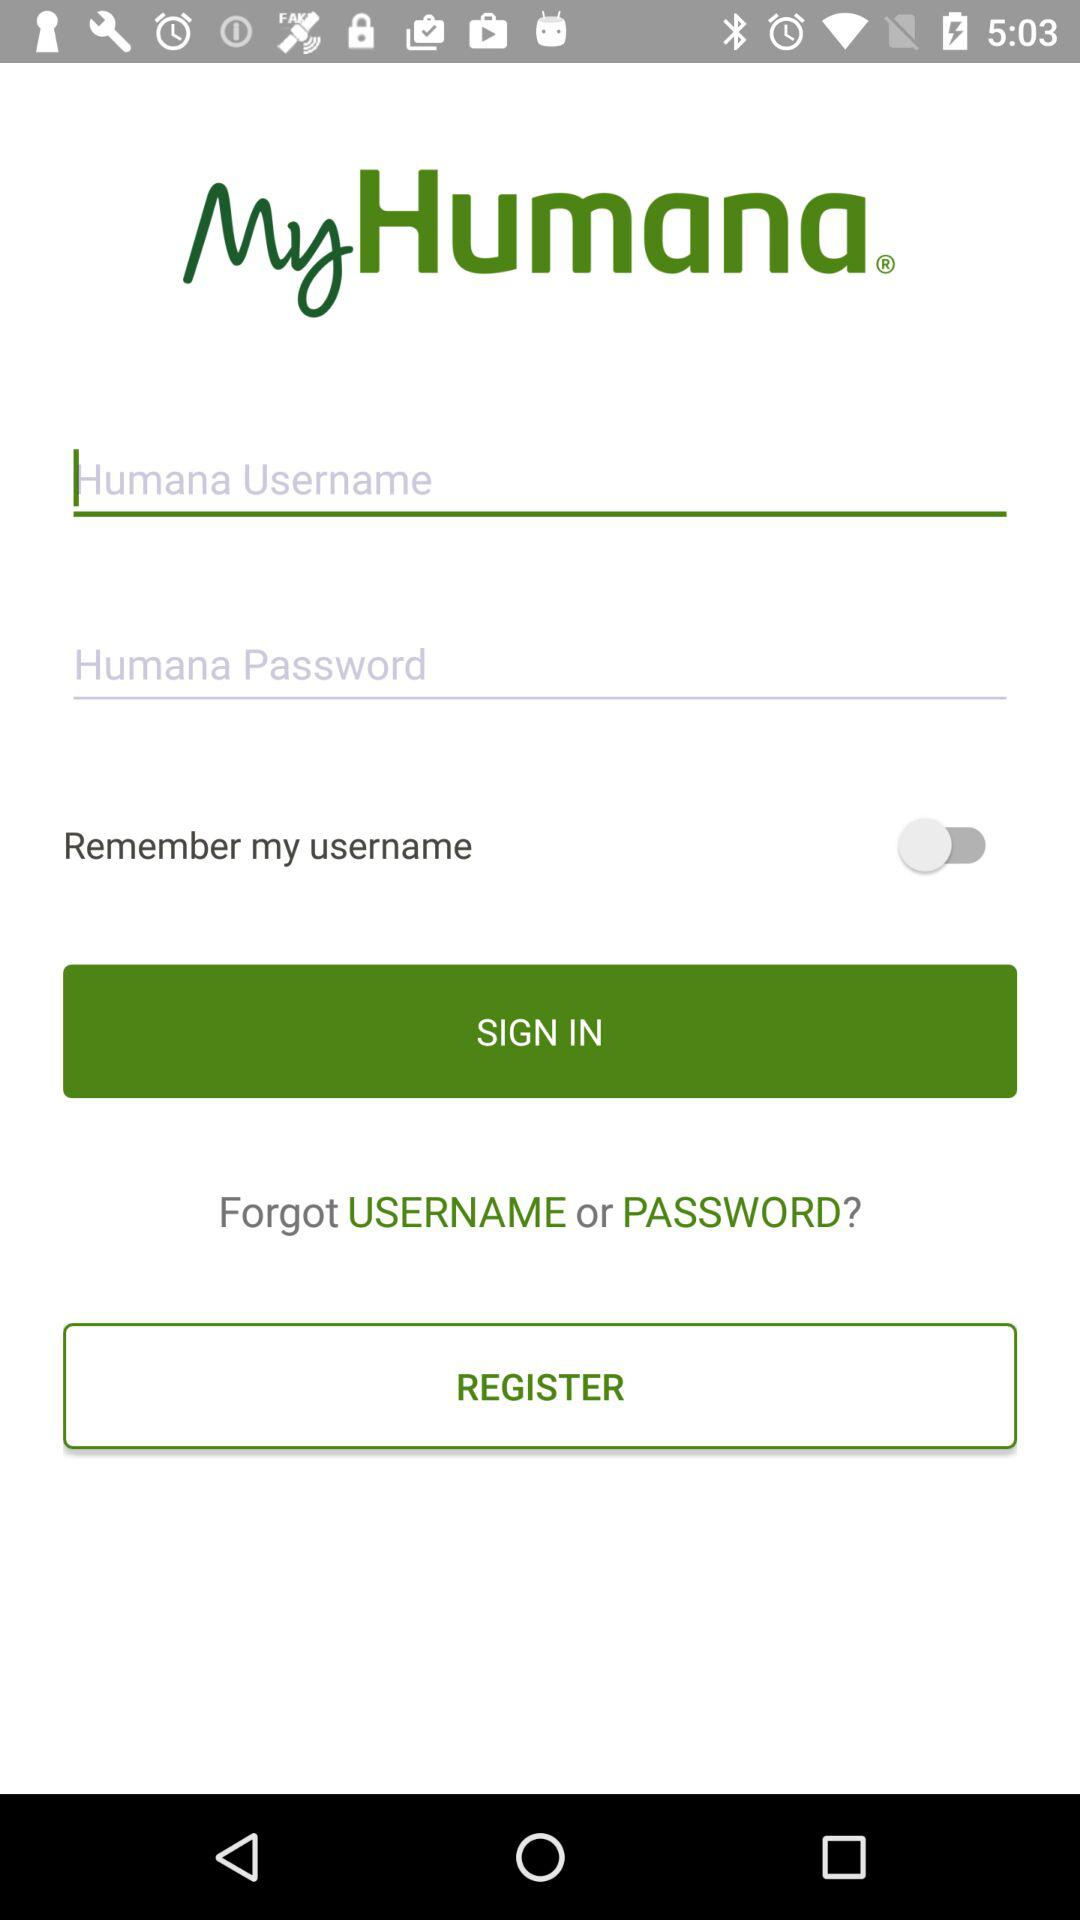What is the status of remember my username? The status is off. 